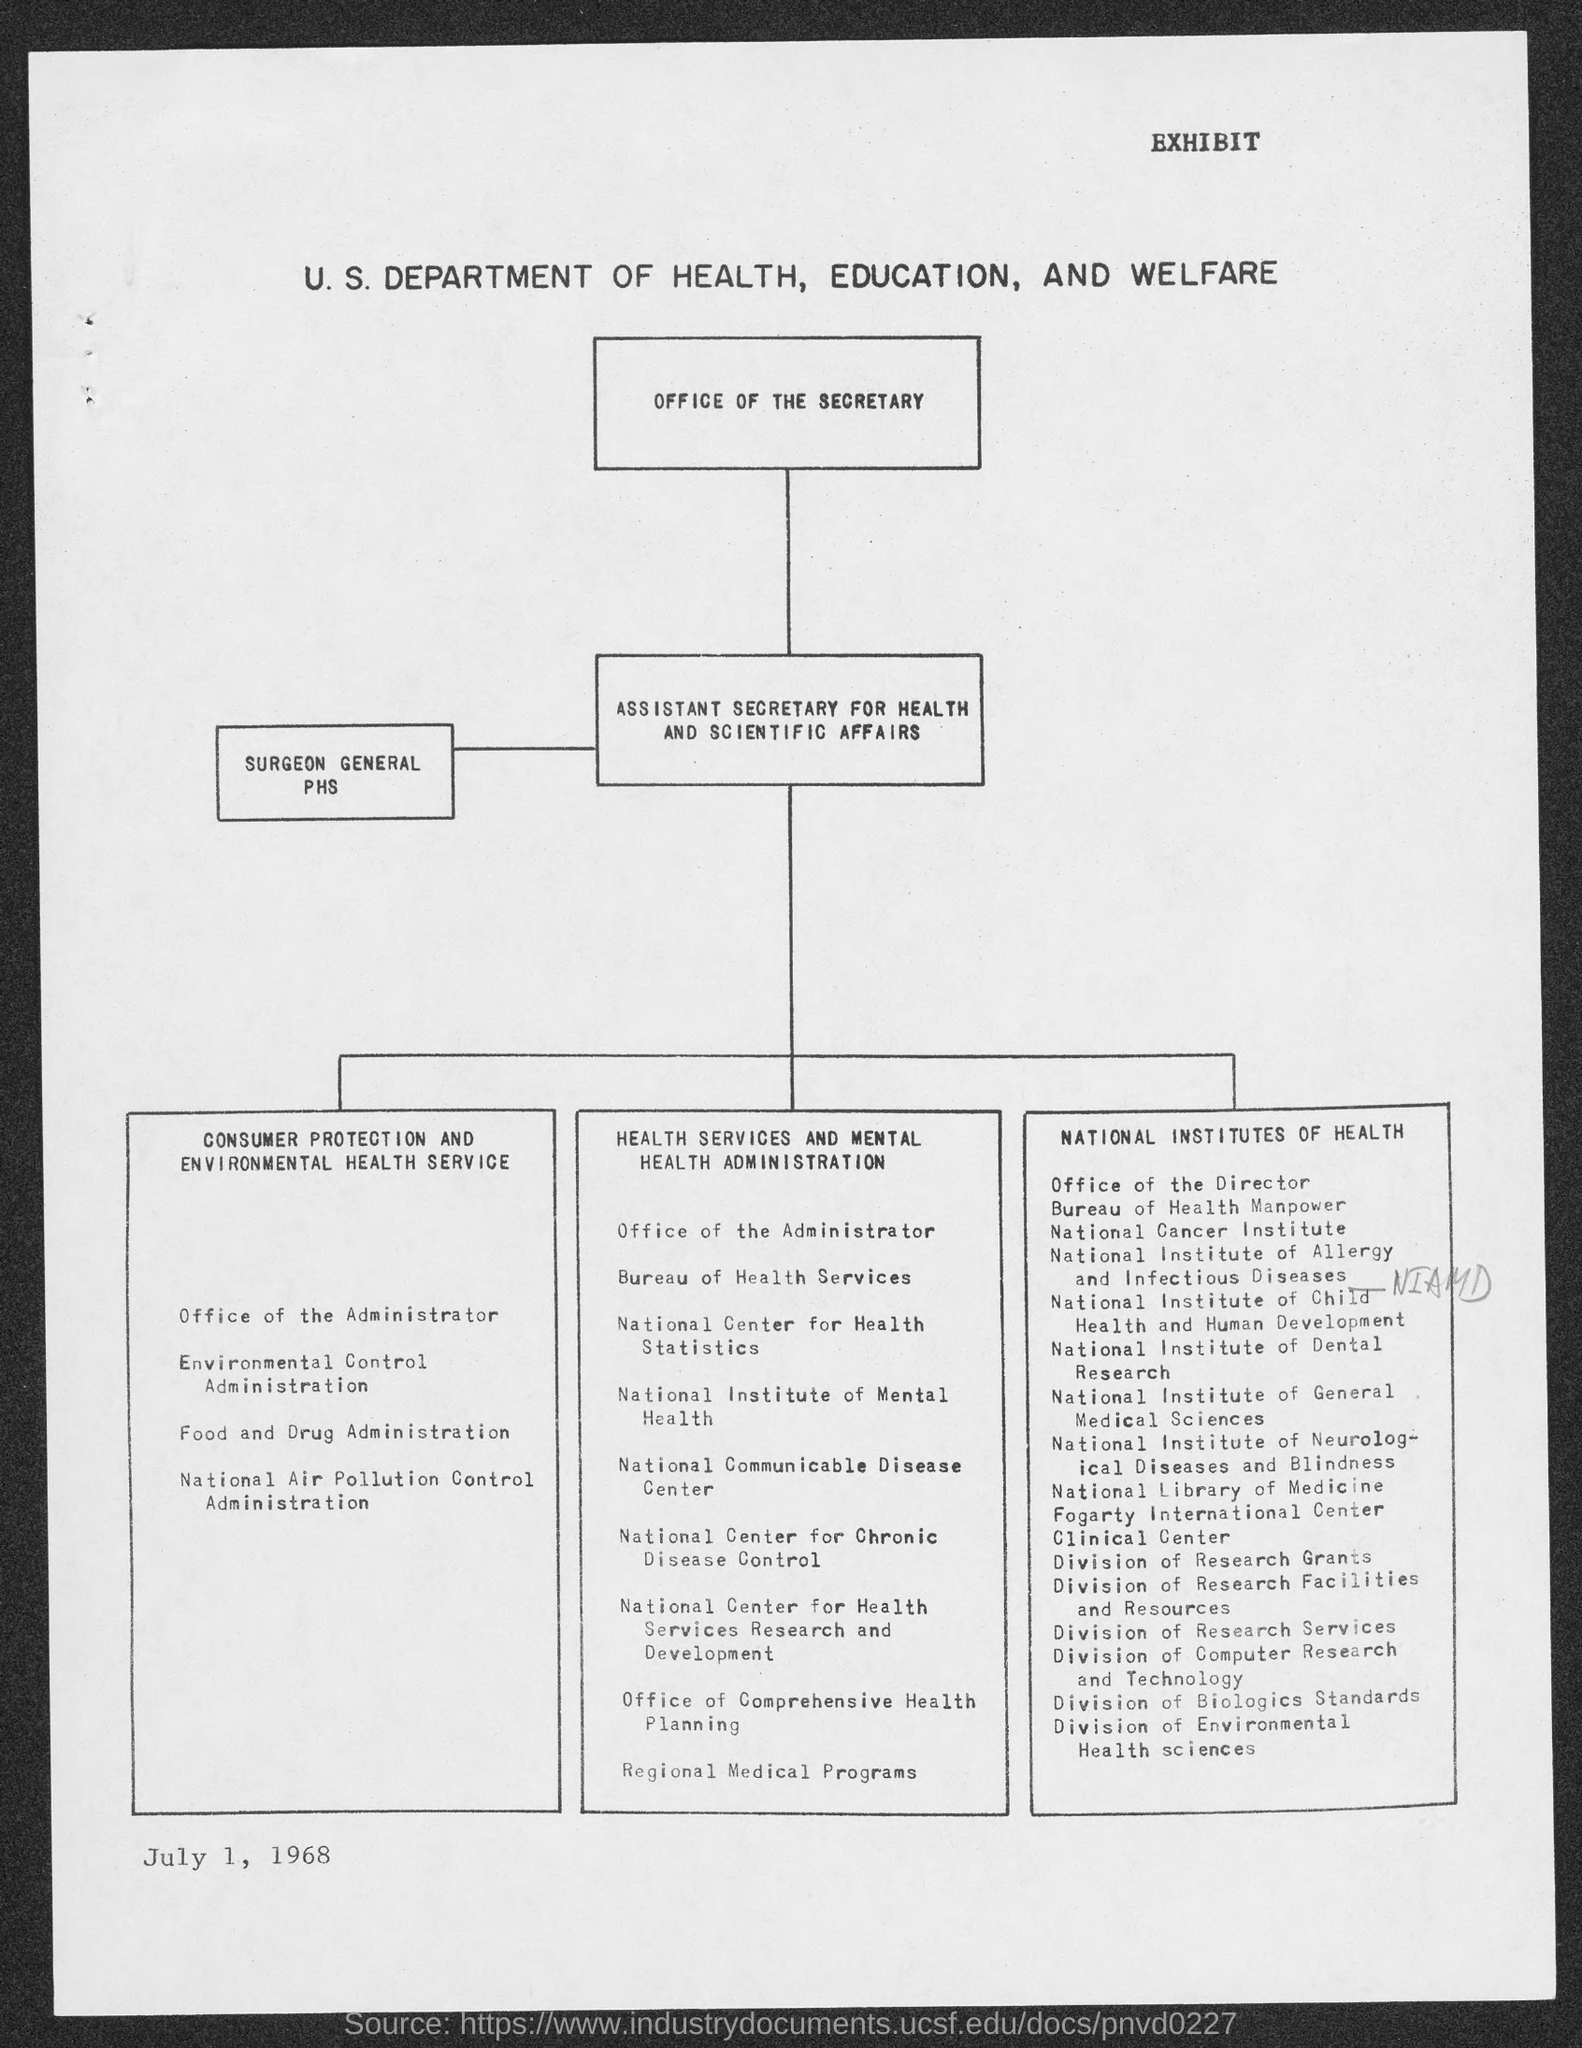What is the date?
Provide a short and direct response. JULY 1, 1968. What is written at the top of the document?
Give a very brief answer. EXHIBIT. 